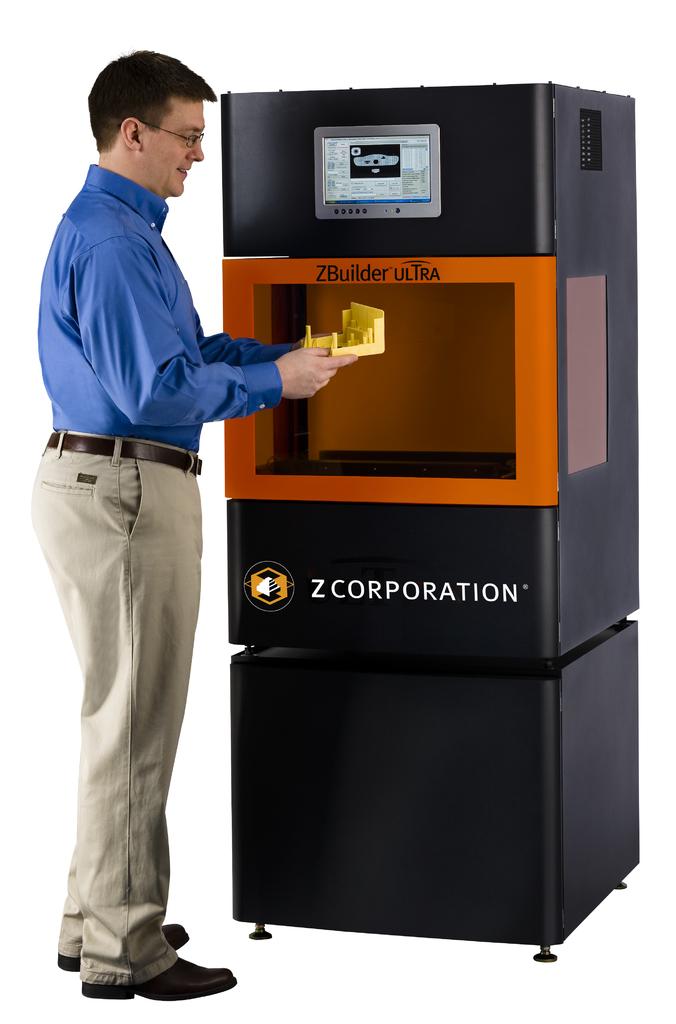Who branded this machine?
Make the answer very short. Zcorporation. What company made the machine?
Provide a short and direct response. Z corporation. 